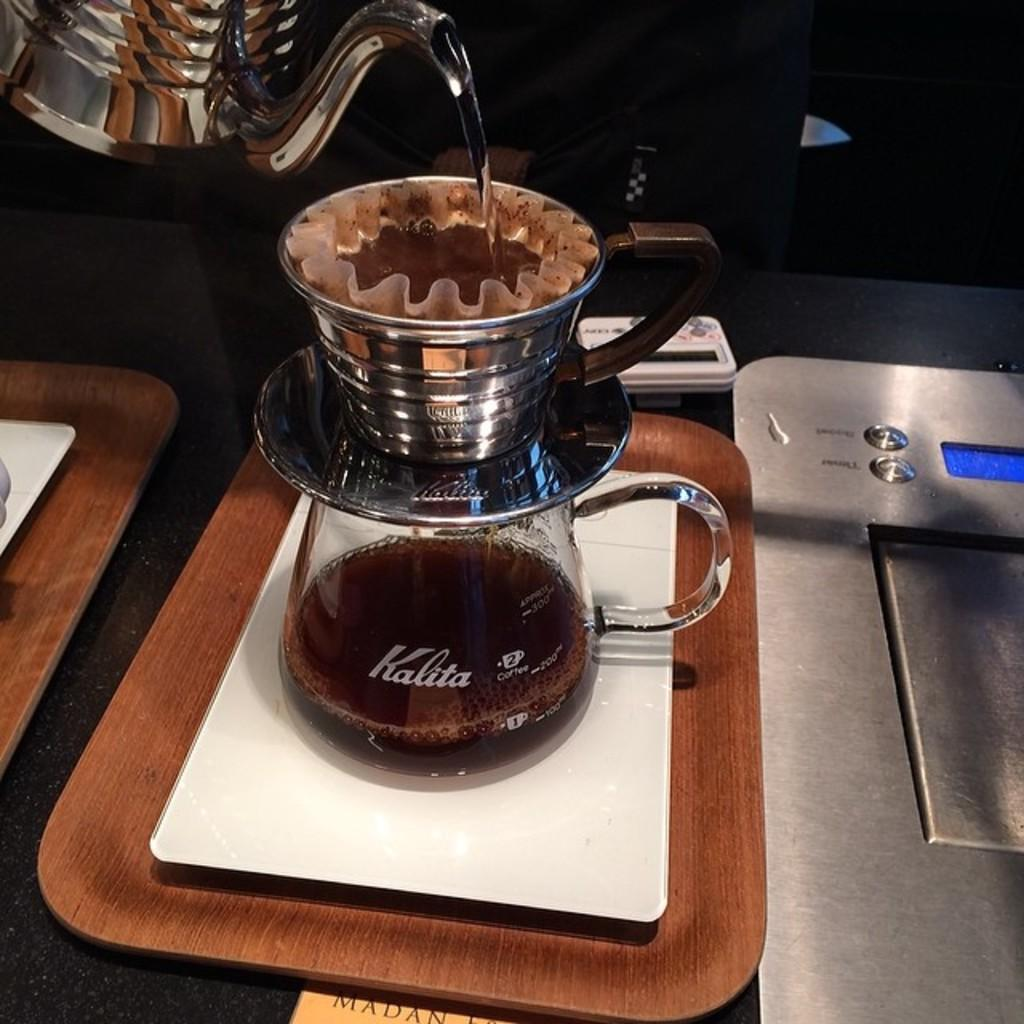<image>
Share a concise interpretation of the image provided. a coffee pot with the word Kalita written on it 